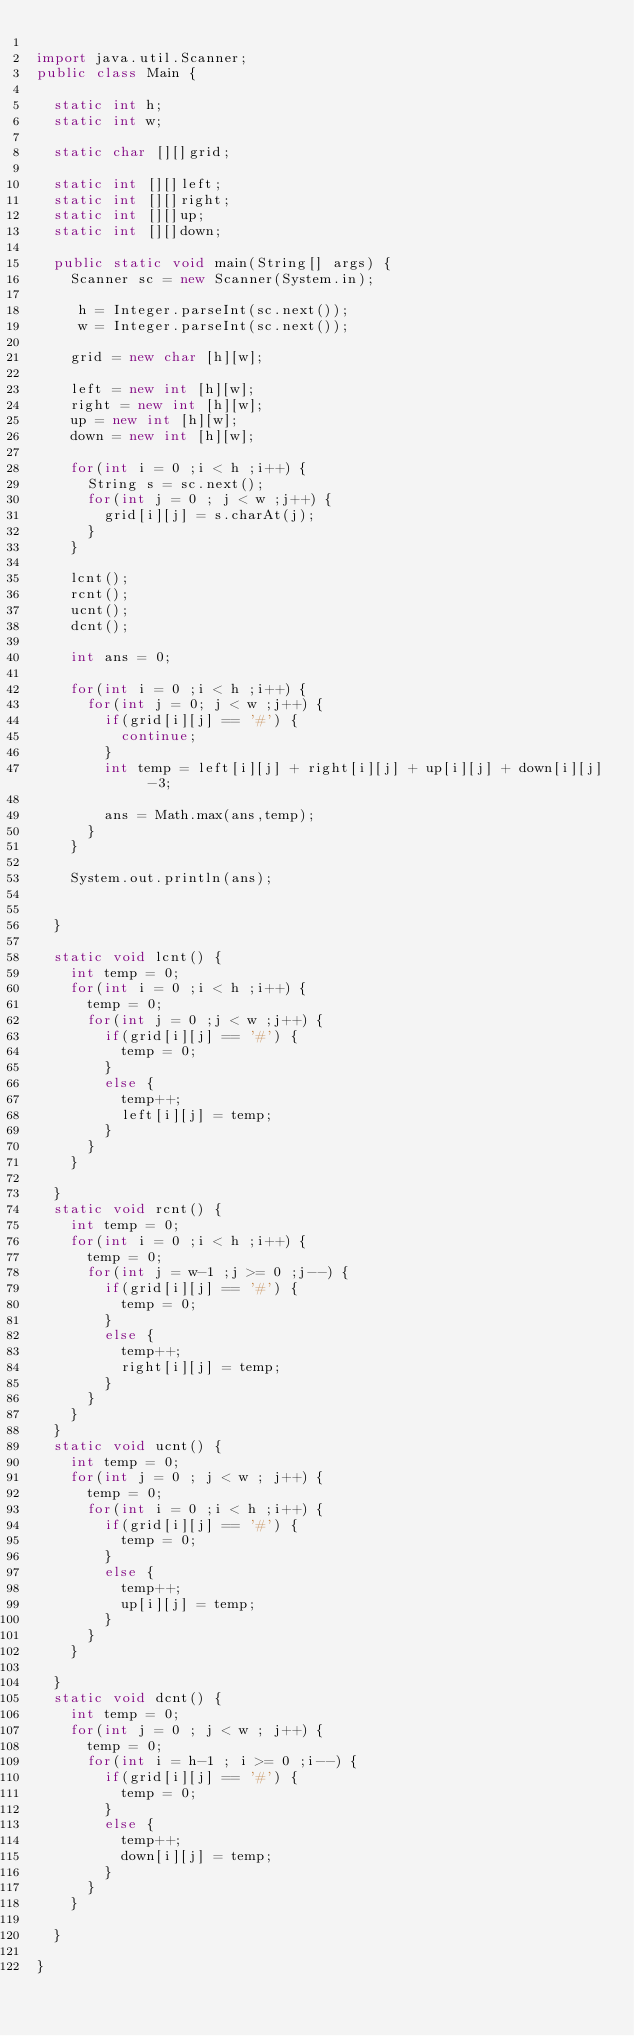Convert code to text. <code><loc_0><loc_0><loc_500><loc_500><_Java_>
import java.util.Scanner;
public class Main {
	
	static int h;
	static int w;
	
	static char [][]grid;
	
	static int [][]left;
	static int [][]right;
	static int [][]up;
	static int [][]down;

	public static void main(String[] args) {
		Scanner sc = new Scanner(System.in);
		
		 h = Integer.parseInt(sc.next());
		 w = Integer.parseInt(sc.next());
		
		grid = new char [h][w];
		
		left = new int [h][w];
		right = new int [h][w];
		up = new int [h][w];
		down = new int [h][w];
		
		for(int i = 0 ;i < h ;i++) {
			String s = sc.next();
			for(int j = 0 ; j < w ;j++) {
				grid[i][j] = s.charAt(j);
			}
		}
		
		lcnt();
		rcnt();
		ucnt();
		dcnt();
		
		int ans = 0;
		
		for(int i = 0 ;i < h ;i++) {
			for(int j = 0; j < w ;j++) {
				if(grid[i][j] == '#') {
					continue;
				}
				int temp = left[i][j] + right[i][j] + up[i][j] + down[i][j] -3;
				
				ans = Math.max(ans,temp);
			}
		}
		
		System.out.println(ans);
	

	}
	
	static void lcnt() {
		int temp = 0;
		for(int i = 0 ;i < h ;i++) {
			temp = 0;
			for(int j = 0 ;j < w ;j++) {
				if(grid[i][j] == '#') {
					temp = 0;
				}
				else {
					temp++;
					left[i][j] = temp;
				}
			}
		}
		
	}
	static void rcnt() {
		int temp = 0;
		for(int i = 0 ;i < h ;i++) {
			temp = 0;
			for(int j = w-1 ;j >= 0 ;j--) {
				if(grid[i][j] == '#') {
					temp = 0;
				}
				else {
					temp++;
					right[i][j] = temp;
				}
			}
		}
	}
	static void ucnt() {
		int temp = 0;
		for(int j = 0 ; j < w ; j++) {
			temp = 0;
			for(int i = 0 ;i < h ;i++) {
				if(grid[i][j] == '#') {
					temp = 0;
				}
				else {
					temp++;
					up[i][j] = temp;
				}
			}
		}
		
	}
	static void dcnt() {
		int temp = 0;
		for(int j = 0 ; j < w ; j++) {
			temp = 0;
			for(int i = h-1 ; i >= 0 ;i--) {
				if(grid[i][j] == '#') {
					temp = 0;
				}
				else {
					temp++;
					down[i][j] = temp;
				}
			}
		}
		
	}

}
</code> 